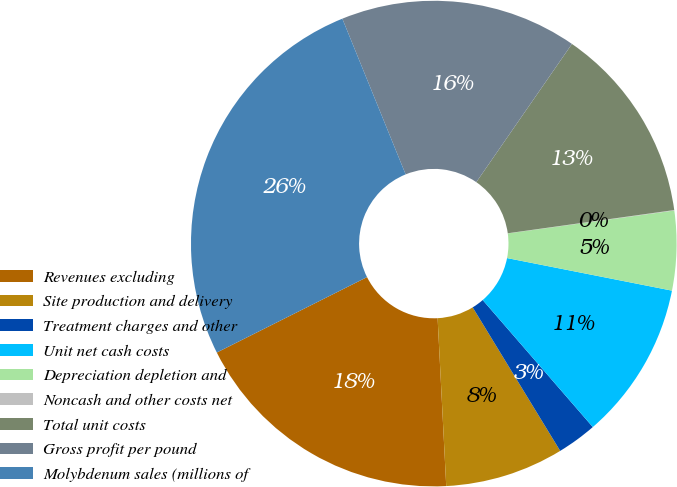Convert chart. <chart><loc_0><loc_0><loc_500><loc_500><pie_chart><fcel>Revenues excluding<fcel>Site production and delivery<fcel>Treatment charges and other<fcel>Unit net cash costs<fcel>Depreciation depletion and<fcel>Noncash and other costs net<fcel>Total unit costs<fcel>Gross profit per pound<fcel>Molybdenum sales (millions of<nl><fcel>18.41%<fcel>7.9%<fcel>2.65%<fcel>10.53%<fcel>5.28%<fcel>0.03%<fcel>13.16%<fcel>15.78%<fcel>26.26%<nl></chart> 